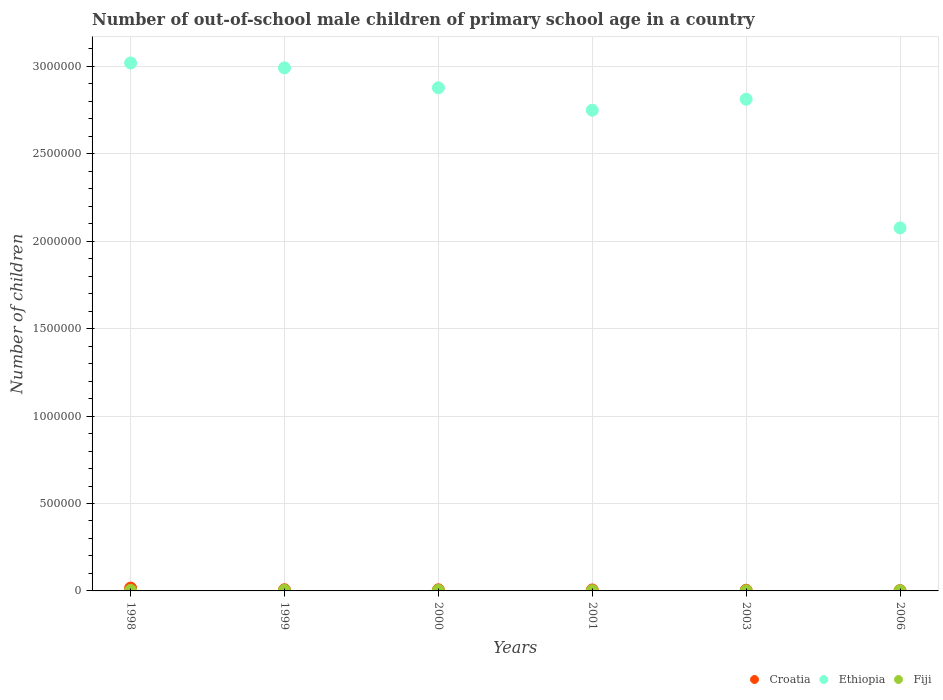How many different coloured dotlines are there?
Your response must be concise. 3. Is the number of dotlines equal to the number of legend labels?
Ensure brevity in your answer.  Yes. What is the number of out-of-school male children in Fiji in 1999?
Provide a succinct answer. 3458. Across all years, what is the maximum number of out-of-school male children in Croatia?
Give a very brief answer. 1.62e+04. Across all years, what is the minimum number of out-of-school male children in Fiji?
Ensure brevity in your answer.  914. In which year was the number of out-of-school male children in Croatia maximum?
Provide a succinct answer. 1998. What is the total number of out-of-school male children in Fiji in the graph?
Provide a short and direct response. 1.29e+04. What is the difference between the number of out-of-school male children in Ethiopia in 1999 and that in 2003?
Give a very brief answer. 1.79e+05. What is the difference between the number of out-of-school male children in Croatia in 2003 and the number of out-of-school male children in Ethiopia in 1999?
Your response must be concise. -2.99e+06. What is the average number of out-of-school male children in Fiji per year?
Ensure brevity in your answer.  2145.67. In the year 2003, what is the difference between the number of out-of-school male children in Ethiopia and number of out-of-school male children in Croatia?
Your answer should be very brief. 2.81e+06. What is the ratio of the number of out-of-school male children in Fiji in 2000 to that in 2001?
Your answer should be very brief. 2.16. Is the number of out-of-school male children in Ethiopia in 2003 less than that in 2006?
Provide a short and direct response. No. Is the difference between the number of out-of-school male children in Ethiopia in 1999 and 2003 greater than the difference between the number of out-of-school male children in Croatia in 1999 and 2003?
Your answer should be compact. Yes. What is the difference between the highest and the second highest number of out-of-school male children in Ethiopia?
Provide a succinct answer. 2.80e+04. What is the difference between the highest and the lowest number of out-of-school male children in Croatia?
Your answer should be compact. 1.46e+04. Is the sum of the number of out-of-school male children in Fiji in 2000 and 2003 greater than the maximum number of out-of-school male children in Croatia across all years?
Provide a short and direct response. No. Does the number of out-of-school male children in Ethiopia monotonically increase over the years?
Provide a short and direct response. No. Is the number of out-of-school male children in Fiji strictly greater than the number of out-of-school male children in Ethiopia over the years?
Make the answer very short. No. How many dotlines are there?
Provide a succinct answer. 3. How many years are there in the graph?
Offer a terse response. 6. Does the graph contain grids?
Offer a terse response. Yes. Where does the legend appear in the graph?
Offer a very short reply. Bottom right. What is the title of the graph?
Make the answer very short. Number of out-of-school male children of primary school age in a country. What is the label or title of the Y-axis?
Ensure brevity in your answer.  Number of children. What is the Number of children of Croatia in 1998?
Make the answer very short. 1.62e+04. What is the Number of children in Ethiopia in 1998?
Your response must be concise. 3.02e+06. What is the Number of children of Fiji in 1998?
Offer a terse response. 3018. What is the Number of children of Croatia in 1999?
Offer a very short reply. 6765. What is the Number of children in Ethiopia in 1999?
Make the answer very short. 2.99e+06. What is the Number of children of Fiji in 1999?
Your response must be concise. 3458. What is the Number of children of Croatia in 2000?
Make the answer very short. 6522. What is the Number of children in Ethiopia in 2000?
Your response must be concise. 2.88e+06. What is the Number of children in Fiji in 2000?
Your answer should be very brief. 3094. What is the Number of children of Croatia in 2001?
Keep it short and to the point. 5639. What is the Number of children of Ethiopia in 2001?
Offer a terse response. 2.75e+06. What is the Number of children of Fiji in 2001?
Make the answer very short. 1433. What is the Number of children in Croatia in 2003?
Offer a terse response. 3994. What is the Number of children of Ethiopia in 2003?
Your response must be concise. 2.81e+06. What is the Number of children in Fiji in 2003?
Provide a succinct answer. 957. What is the Number of children in Croatia in 2006?
Your answer should be compact. 1613. What is the Number of children of Ethiopia in 2006?
Provide a succinct answer. 2.08e+06. What is the Number of children in Fiji in 2006?
Make the answer very short. 914. Across all years, what is the maximum Number of children in Croatia?
Provide a succinct answer. 1.62e+04. Across all years, what is the maximum Number of children in Ethiopia?
Offer a very short reply. 3.02e+06. Across all years, what is the maximum Number of children in Fiji?
Give a very brief answer. 3458. Across all years, what is the minimum Number of children of Croatia?
Offer a very short reply. 1613. Across all years, what is the minimum Number of children of Ethiopia?
Make the answer very short. 2.08e+06. Across all years, what is the minimum Number of children in Fiji?
Your answer should be compact. 914. What is the total Number of children of Croatia in the graph?
Your answer should be very brief. 4.08e+04. What is the total Number of children of Ethiopia in the graph?
Provide a short and direct response. 1.65e+07. What is the total Number of children of Fiji in the graph?
Offer a terse response. 1.29e+04. What is the difference between the Number of children in Croatia in 1998 and that in 1999?
Offer a terse response. 9472. What is the difference between the Number of children of Ethiopia in 1998 and that in 1999?
Keep it short and to the point. 2.80e+04. What is the difference between the Number of children in Fiji in 1998 and that in 1999?
Keep it short and to the point. -440. What is the difference between the Number of children in Croatia in 1998 and that in 2000?
Offer a terse response. 9715. What is the difference between the Number of children in Ethiopia in 1998 and that in 2000?
Your answer should be compact. 1.42e+05. What is the difference between the Number of children in Fiji in 1998 and that in 2000?
Your response must be concise. -76. What is the difference between the Number of children in Croatia in 1998 and that in 2001?
Your response must be concise. 1.06e+04. What is the difference between the Number of children of Ethiopia in 1998 and that in 2001?
Give a very brief answer. 2.70e+05. What is the difference between the Number of children of Fiji in 1998 and that in 2001?
Your answer should be compact. 1585. What is the difference between the Number of children of Croatia in 1998 and that in 2003?
Your answer should be very brief. 1.22e+04. What is the difference between the Number of children of Ethiopia in 1998 and that in 2003?
Give a very brief answer. 2.07e+05. What is the difference between the Number of children in Fiji in 1998 and that in 2003?
Make the answer very short. 2061. What is the difference between the Number of children of Croatia in 1998 and that in 2006?
Your answer should be compact. 1.46e+04. What is the difference between the Number of children in Ethiopia in 1998 and that in 2006?
Offer a terse response. 9.43e+05. What is the difference between the Number of children of Fiji in 1998 and that in 2006?
Keep it short and to the point. 2104. What is the difference between the Number of children of Croatia in 1999 and that in 2000?
Your answer should be compact. 243. What is the difference between the Number of children in Ethiopia in 1999 and that in 2000?
Your response must be concise. 1.14e+05. What is the difference between the Number of children of Fiji in 1999 and that in 2000?
Give a very brief answer. 364. What is the difference between the Number of children in Croatia in 1999 and that in 2001?
Provide a succinct answer. 1126. What is the difference between the Number of children in Ethiopia in 1999 and that in 2001?
Offer a terse response. 2.42e+05. What is the difference between the Number of children of Fiji in 1999 and that in 2001?
Your answer should be compact. 2025. What is the difference between the Number of children in Croatia in 1999 and that in 2003?
Provide a short and direct response. 2771. What is the difference between the Number of children of Ethiopia in 1999 and that in 2003?
Keep it short and to the point. 1.79e+05. What is the difference between the Number of children of Fiji in 1999 and that in 2003?
Your response must be concise. 2501. What is the difference between the Number of children in Croatia in 1999 and that in 2006?
Provide a succinct answer. 5152. What is the difference between the Number of children in Ethiopia in 1999 and that in 2006?
Your response must be concise. 9.15e+05. What is the difference between the Number of children of Fiji in 1999 and that in 2006?
Provide a succinct answer. 2544. What is the difference between the Number of children of Croatia in 2000 and that in 2001?
Make the answer very short. 883. What is the difference between the Number of children in Ethiopia in 2000 and that in 2001?
Offer a terse response. 1.28e+05. What is the difference between the Number of children in Fiji in 2000 and that in 2001?
Provide a succinct answer. 1661. What is the difference between the Number of children in Croatia in 2000 and that in 2003?
Keep it short and to the point. 2528. What is the difference between the Number of children in Ethiopia in 2000 and that in 2003?
Offer a terse response. 6.54e+04. What is the difference between the Number of children of Fiji in 2000 and that in 2003?
Keep it short and to the point. 2137. What is the difference between the Number of children of Croatia in 2000 and that in 2006?
Your answer should be compact. 4909. What is the difference between the Number of children of Ethiopia in 2000 and that in 2006?
Your response must be concise. 8.01e+05. What is the difference between the Number of children of Fiji in 2000 and that in 2006?
Provide a succinct answer. 2180. What is the difference between the Number of children in Croatia in 2001 and that in 2003?
Provide a succinct answer. 1645. What is the difference between the Number of children in Ethiopia in 2001 and that in 2003?
Provide a succinct answer. -6.30e+04. What is the difference between the Number of children of Fiji in 2001 and that in 2003?
Ensure brevity in your answer.  476. What is the difference between the Number of children in Croatia in 2001 and that in 2006?
Offer a very short reply. 4026. What is the difference between the Number of children of Ethiopia in 2001 and that in 2006?
Your answer should be compact. 6.73e+05. What is the difference between the Number of children in Fiji in 2001 and that in 2006?
Keep it short and to the point. 519. What is the difference between the Number of children in Croatia in 2003 and that in 2006?
Your response must be concise. 2381. What is the difference between the Number of children of Ethiopia in 2003 and that in 2006?
Your answer should be very brief. 7.36e+05. What is the difference between the Number of children in Croatia in 1998 and the Number of children in Ethiopia in 1999?
Ensure brevity in your answer.  -2.98e+06. What is the difference between the Number of children of Croatia in 1998 and the Number of children of Fiji in 1999?
Offer a very short reply. 1.28e+04. What is the difference between the Number of children in Ethiopia in 1998 and the Number of children in Fiji in 1999?
Offer a terse response. 3.02e+06. What is the difference between the Number of children of Croatia in 1998 and the Number of children of Ethiopia in 2000?
Your answer should be compact. -2.86e+06. What is the difference between the Number of children of Croatia in 1998 and the Number of children of Fiji in 2000?
Provide a succinct answer. 1.31e+04. What is the difference between the Number of children of Ethiopia in 1998 and the Number of children of Fiji in 2000?
Provide a short and direct response. 3.02e+06. What is the difference between the Number of children of Croatia in 1998 and the Number of children of Ethiopia in 2001?
Provide a short and direct response. -2.73e+06. What is the difference between the Number of children in Croatia in 1998 and the Number of children in Fiji in 2001?
Your response must be concise. 1.48e+04. What is the difference between the Number of children in Ethiopia in 1998 and the Number of children in Fiji in 2001?
Your response must be concise. 3.02e+06. What is the difference between the Number of children in Croatia in 1998 and the Number of children in Ethiopia in 2003?
Provide a succinct answer. -2.80e+06. What is the difference between the Number of children of Croatia in 1998 and the Number of children of Fiji in 2003?
Offer a terse response. 1.53e+04. What is the difference between the Number of children of Ethiopia in 1998 and the Number of children of Fiji in 2003?
Ensure brevity in your answer.  3.02e+06. What is the difference between the Number of children of Croatia in 1998 and the Number of children of Ethiopia in 2006?
Offer a terse response. -2.06e+06. What is the difference between the Number of children in Croatia in 1998 and the Number of children in Fiji in 2006?
Provide a short and direct response. 1.53e+04. What is the difference between the Number of children of Ethiopia in 1998 and the Number of children of Fiji in 2006?
Ensure brevity in your answer.  3.02e+06. What is the difference between the Number of children in Croatia in 1999 and the Number of children in Ethiopia in 2000?
Keep it short and to the point. -2.87e+06. What is the difference between the Number of children in Croatia in 1999 and the Number of children in Fiji in 2000?
Make the answer very short. 3671. What is the difference between the Number of children in Ethiopia in 1999 and the Number of children in Fiji in 2000?
Offer a terse response. 2.99e+06. What is the difference between the Number of children of Croatia in 1999 and the Number of children of Ethiopia in 2001?
Keep it short and to the point. -2.74e+06. What is the difference between the Number of children of Croatia in 1999 and the Number of children of Fiji in 2001?
Provide a succinct answer. 5332. What is the difference between the Number of children of Ethiopia in 1999 and the Number of children of Fiji in 2001?
Provide a short and direct response. 2.99e+06. What is the difference between the Number of children of Croatia in 1999 and the Number of children of Ethiopia in 2003?
Provide a short and direct response. -2.81e+06. What is the difference between the Number of children in Croatia in 1999 and the Number of children in Fiji in 2003?
Offer a terse response. 5808. What is the difference between the Number of children in Ethiopia in 1999 and the Number of children in Fiji in 2003?
Offer a very short reply. 2.99e+06. What is the difference between the Number of children in Croatia in 1999 and the Number of children in Ethiopia in 2006?
Your response must be concise. -2.07e+06. What is the difference between the Number of children of Croatia in 1999 and the Number of children of Fiji in 2006?
Offer a very short reply. 5851. What is the difference between the Number of children of Ethiopia in 1999 and the Number of children of Fiji in 2006?
Ensure brevity in your answer.  2.99e+06. What is the difference between the Number of children of Croatia in 2000 and the Number of children of Ethiopia in 2001?
Your answer should be compact. -2.74e+06. What is the difference between the Number of children of Croatia in 2000 and the Number of children of Fiji in 2001?
Offer a terse response. 5089. What is the difference between the Number of children in Ethiopia in 2000 and the Number of children in Fiji in 2001?
Your answer should be very brief. 2.88e+06. What is the difference between the Number of children in Croatia in 2000 and the Number of children in Ethiopia in 2003?
Give a very brief answer. -2.81e+06. What is the difference between the Number of children in Croatia in 2000 and the Number of children in Fiji in 2003?
Ensure brevity in your answer.  5565. What is the difference between the Number of children in Ethiopia in 2000 and the Number of children in Fiji in 2003?
Your answer should be compact. 2.88e+06. What is the difference between the Number of children in Croatia in 2000 and the Number of children in Ethiopia in 2006?
Keep it short and to the point. -2.07e+06. What is the difference between the Number of children of Croatia in 2000 and the Number of children of Fiji in 2006?
Your response must be concise. 5608. What is the difference between the Number of children of Ethiopia in 2000 and the Number of children of Fiji in 2006?
Provide a succinct answer. 2.88e+06. What is the difference between the Number of children in Croatia in 2001 and the Number of children in Ethiopia in 2003?
Provide a short and direct response. -2.81e+06. What is the difference between the Number of children in Croatia in 2001 and the Number of children in Fiji in 2003?
Ensure brevity in your answer.  4682. What is the difference between the Number of children of Ethiopia in 2001 and the Number of children of Fiji in 2003?
Ensure brevity in your answer.  2.75e+06. What is the difference between the Number of children in Croatia in 2001 and the Number of children in Ethiopia in 2006?
Offer a terse response. -2.07e+06. What is the difference between the Number of children in Croatia in 2001 and the Number of children in Fiji in 2006?
Provide a short and direct response. 4725. What is the difference between the Number of children in Ethiopia in 2001 and the Number of children in Fiji in 2006?
Your response must be concise. 2.75e+06. What is the difference between the Number of children in Croatia in 2003 and the Number of children in Ethiopia in 2006?
Give a very brief answer. -2.07e+06. What is the difference between the Number of children of Croatia in 2003 and the Number of children of Fiji in 2006?
Your response must be concise. 3080. What is the difference between the Number of children in Ethiopia in 2003 and the Number of children in Fiji in 2006?
Your response must be concise. 2.81e+06. What is the average Number of children in Croatia per year?
Make the answer very short. 6795. What is the average Number of children of Ethiopia per year?
Your answer should be very brief. 2.75e+06. What is the average Number of children in Fiji per year?
Keep it short and to the point. 2145.67. In the year 1998, what is the difference between the Number of children of Croatia and Number of children of Ethiopia?
Ensure brevity in your answer.  -3.00e+06. In the year 1998, what is the difference between the Number of children in Croatia and Number of children in Fiji?
Make the answer very short. 1.32e+04. In the year 1998, what is the difference between the Number of children of Ethiopia and Number of children of Fiji?
Your answer should be compact. 3.02e+06. In the year 1999, what is the difference between the Number of children in Croatia and Number of children in Ethiopia?
Your answer should be very brief. -2.98e+06. In the year 1999, what is the difference between the Number of children of Croatia and Number of children of Fiji?
Give a very brief answer. 3307. In the year 1999, what is the difference between the Number of children of Ethiopia and Number of children of Fiji?
Ensure brevity in your answer.  2.99e+06. In the year 2000, what is the difference between the Number of children of Croatia and Number of children of Ethiopia?
Make the answer very short. -2.87e+06. In the year 2000, what is the difference between the Number of children in Croatia and Number of children in Fiji?
Make the answer very short. 3428. In the year 2000, what is the difference between the Number of children of Ethiopia and Number of children of Fiji?
Your answer should be compact. 2.87e+06. In the year 2001, what is the difference between the Number of children of Croatia and Number of children of Ethiopia?
Keep it short and to the point. -2.74e+06. In the year 2001, what is the difference between the Number of children in Croatia and Number of children in Fiji?
Your answer should be compact. 4206. In the year 2001, what is the difference between the Number of children in Ethiopia and Number of children in Fiji?
Your response must be concise. 2.75e+06. In the year 2003, what is the difference between the Number of children of Croatia and Number of children of Ethiopia?
Provide a short and direct response. -2.81e+06. In the year 2003, what is the difference between the Number of children in Croatia and Number of children in Fiji?
Offer a very short reply. 3037. In the year 2003, what is the difference between the Number of children in Ethiopia and Number of children in Fiji?
Your answer should be very brief. 2.81e+06. In the year 2006, what is the difference between the Number of children in Croatia and Number of children in Ethiopia?
Give a very brief answer. -2.07e+06. In the year 2006, what is the difference between the Number of children of Croatia and Number of children of Fiji?
Give a very brief answer. 699. In the year 2006, what is the difference between the Number of children of Ethiopia and Number of children of Fiji?
Provide a succinct answer. 2.08e+06. What is the ratio of the Number of children of Croatia in 1998 to that in 1999?
Provide a succinct answer. 2.4. What is the ratio of the Number of children in Ethiopia in 1998 to that in 1999?
Your answer should be very brief. 1.01. What is the ratio of the Number of children of Fiji in 1998 to that in 1999?
Keep it short and to the point. 0.87. What is the ratio of the Number of children in Croatia in 1998 to that in 2000?
Offer a very short reply. 2.49. What is the ratio of the Number of children in Ethiopia in 1998 to that in 2000?
Your answer should be very brief. 1.05. What is the ratio of the Number of children in Fiji in 1998 to that in 2000?
Give a very brief answer. 0.98. What is the ratio of the Number of children in Croatia in 1998 to that in 2001?
Provide a short and direct response. 2.88. What is the ratio of the Number of children in Ethiopia in 1998 to that in 2001?
Offer a very short reply. 1.1. What is the ratio of the Number of children in Fiji in 1998 to that in 2001?
Your answer should be very brief. 2.11. What is the ratio of the Number of children in Croatia in 1998 to that in 2003?
Your response must be concise. 4.07. What is the ratio of the Number of children in Ethiopia in 1998 to that in 2003?
Your response must be concise. 1.07. What is the ratio of the Number of children in Fiji in 1998 to that in 2003?
Ensure brevity in your answer.  3.15. What is the ratio of the Number of children in Croatia in 1998 to that in 2006?
Offer a terse response. 10.07. What is the ratio of the Number of children in Ethiopia in 1998 to that in 2006?
Your response must be concise. 1.45. What is the ratio of the Number of children of Fiji in 1998 to that in 2006?
Give a very brief answer. 3.3. What is the ratio of the Number of children in Croatia in 1999 to that in 2000?
Give a very brief answer. 1.04. What is the ratio of the Number of children in Ethiopia in 1999 to that in 2000?
Offer a terse response. 1.04. What is the ratio of the Number of children in Fiji in 1999 to that in 2000?
Ensure brevity in your answer.  1.12. What is the ratio of the Number of children in Croatia in 1999 to that in 2001?
Keep it short and to the point. 1.2. What is the ratio of the Number of children in Ethiopia in 1999 to that in 2001?
Your answer should be compact. 1.09. What is the ratio of the Number of children in Fiji in 1999 to that in 2001?
Your answer should be compact. 2.41. What is the ratio of the Number of children in Croatia in 1999 to that in 2003?
Your answer should be compact. 1.69. What is the ratio of the Number of children of Ethiopia in 1999 to that in 2003?
Your answer should be very brief. 1.06. What is the ratio of the Number of children of Fiji in 1999 to that in 2003?
Ensure brevity in your answer.  3.61. What is the ratio of the Number of children of Croatia in 1999 to that in 2006?
Your response must be concise. 4.19. What is the ratio of the Number of children in Ethiopia in 1999 to that in 2006?
Ensure brevity in your answer.  1.44. What is the ratio of the Number of children of Fiji in 1999 to that in 2006?
Ensure brevity in your answer.  3.78. What is the ratio of the Number of children in Croatia in 2000 to that in 2001?
Ensure brevity in your answer.  1.16. What is the ratio of the Number of children of Ethiopia in 2000 to that in 2001?
Offer a very short reply. 1.05. What is the ratio of the Number of children of Fiji in 2000 to that in 2001?
Offer a very short reply. 2.16. What is the ratio of the Number of children of Croatia in 2000 to that in 2003?
Provide a succinct answer. 1.63. What is the ratio of the Number of children of Ethiopia in 2000 to that in 2003?
Keep it short and to the point. 1.02. What is the ratio of the Number of children of Fiji in 2000 to that in 2003?
Your answer should be compact. 3.23. What is the ratio of the Number of children of Croatia in 2000 to that in 2006?
Ensure brevity in your answer.  4.04. What is the ratio of the Number of children of Ethiopia in 2000 to that in 2006?
Your answer should be compact. 1.39. What is the ratio of the Number of children of Fiji in 2000 to that in 2006?
Give a very brief answer. 3.39. What is the ratio of the Number of children of Croatia in 2001 to that in 2003?
Provide a short and direct response. 1.41. What is the ratio of the Number of children of Ethiopia in 2001 to that in 2003?
Give a very brief answer. 0.98. What is the ratio of the Number of children of Fiji in 2001 to that in 2003?
Your response must be concise. 1.5. What is the ratio of the Number of children of Croatia in 2001 to that in 2006?
Offer a very short reply. 3.5. What is the ratio of the Number of children in Ethiopia in 2001 to that in 2006?
Your answer should be compact. 1.32. What is the ratio of the Number of children in Fiji in 2001 to that in 2006?
Offer a terse response. 1.57. What is the ratio of the Number of children in Croatia in 2003 to that in 2006?
Ensure brevity in your answer.  2.48. What is the ratio of the Number of children of Ethiopia in 2003 to that in 2006?
Provide a succinct answer. 1.35. What is the ratio of the Number of children in Fiji in 2003 to that in 2006?
Make the answer very short. 1.05. What is the difference between the highest and the second highest Number of children of Croatia?
Offer a terse response. 9472. What is the difference between the highest and the second highest Number of children in Ethiopia?
Provide a succinct answer. 2.80e+04. What is the difference between the highest and the second highest Number of children in Fiji?
Provide a succinct answer. 364. What is the difference between the highest and the lowest Number of children in Croatia?
Your answer should be very brief. 1.46e+04. What is the difference between the highest and the lowest Number of children of Ethiopia?
Your answer should be very brief. 9.43e+05. What is the difference between the highest and the lowest Number of children in Fiji?
Offer a terse response. 2544. 